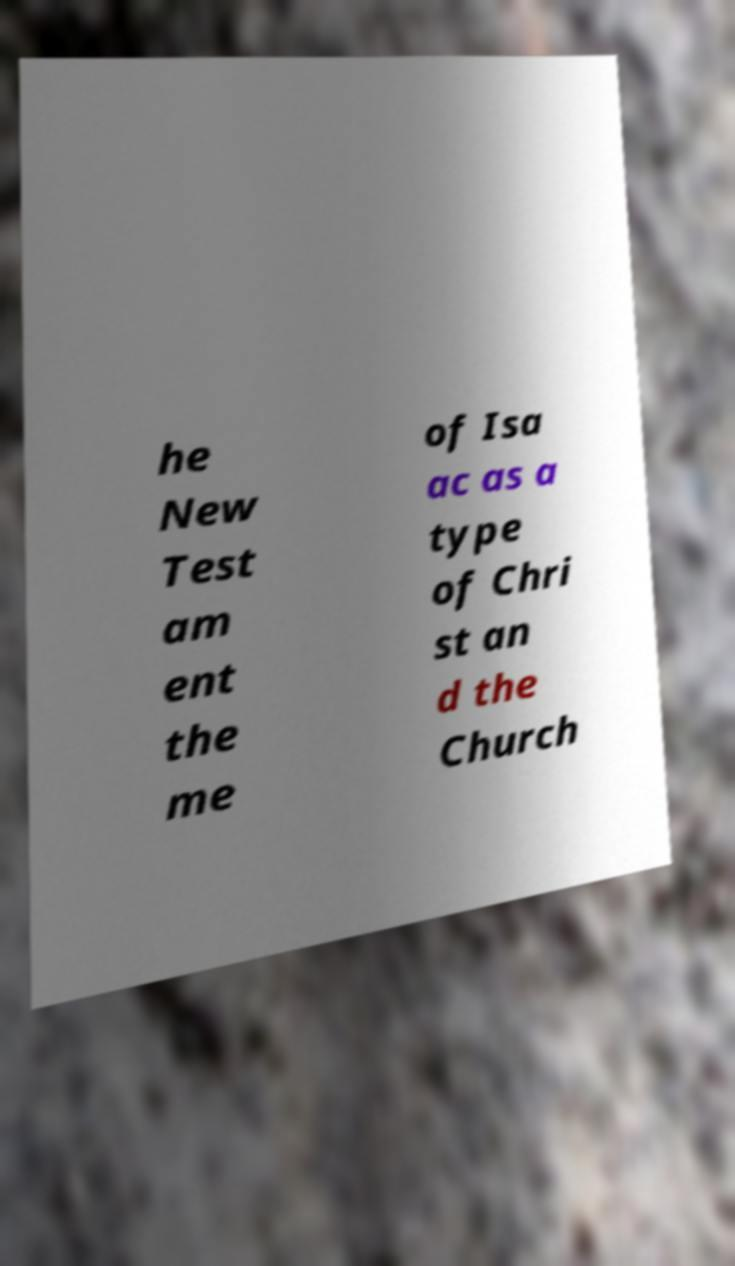Could you extract and type out the text from this image? he New Test am ent the me of Isa ac as a type of Chri st an d the Church 